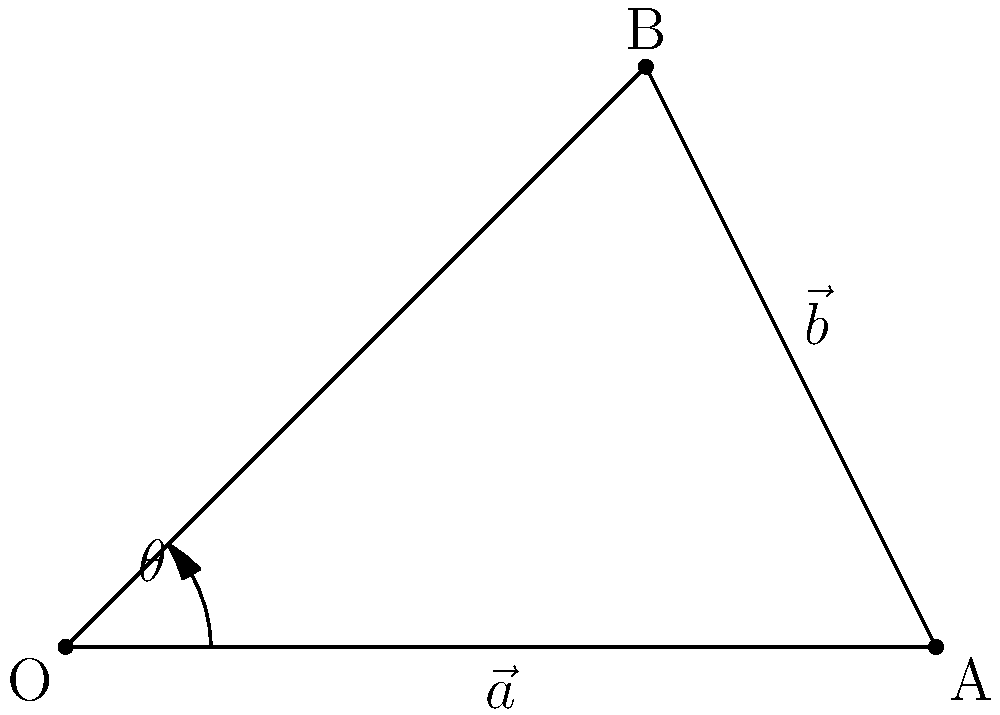In an orchestra setup, two violinists are positioned relative to the conductor. Violinist A is 3 meters directly to the right of the conductor, while violinist B is 2 meters to the right and 2 meters forward. If we represent their positions as vectors $\vec{a}$ and $\vec{b}$ respectively, with the conductor at the origin, what is the angle $\theta$ between these two vectors? Let's approach this step-by-step:

1) First, we need to identify the vectors:
   $\vec{a} = (3, 0)$ and $\vec{b} = (2, 2)$

2) The angle between two vectors can be found using the dot product formula:
   $$\cos \theta = \frac{\vec{a} \cdot \vec{b}}{|\vec{a}||\vec{b}|}$$

3) Let's calculate the dot product $\vec{a} \cdot \vec{b}$:
   $\vec{a} \cdot \vec{b} = (3)(2) + (0)(2) = 6$

4) Now, let's calculate the magnitudes:
   $|\vec{a}| = \sqrt{3^2 + 0^2} = 3$
   $|\vec{b}| = \sqrt{2^2 + 2^2} = 2\sqrt{2}$

5) Substituting into the formula:
   $$\cos \theta = \frac{6}{3(2\sqrt{2})} = \frac{\sqrt{2}}{2}$$

6) To find $\theta$, we take the inverse cosine (arccos) of both sides:
   $$\theta = \arccos(\frac{\sqrt{2}}{2})$$

7) This evaluates to approximately 45 degrees.
Answer: $45°$ or $\frac{\pi}{4}$ radians 